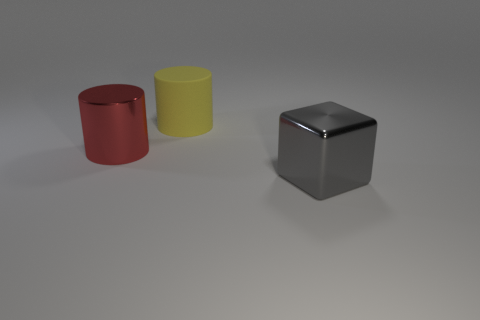There is a metal object that is behind the large shiny thing right of the big metallic object left of the gray metal block; what is its size?
Provide a short and direct response. Large. Are there more large metallic objects that are on the left side of the big rubber cylinder than big gray things?
Give a very brief answer. No. Are any purple cylinders visible?
Offer a very short reply. No. How many blue metal cylinders are the same size as the red cylinder?
Provide a succinct answer. 0. Is the number of big cylinders to the left of the large gray cube greater than the number of yellow cylinders that are on the right side of the rubber cylinder?
Give a very brief answer. Yes. What is the material of the gray block that is the same size as the yellow thing?
Keep it short and to the point. Metal. What is the shape of the large red object?
Provide a short and direct response. Cylinder. How many green things are metal objects or big objects?
Make the answer very short. 0. There is a gray thing that is the same material as the red object; what size is it?
Offer a terse response. Large. Is the material of the big object that is behind the big red shiny cylinder the same as the cylinder in front of the large yellow thing?
Offer a very short reply. No. 